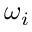<formula> <loc_0><loc_0><loc_500><loc_500>\omega _ { i }</formula> 